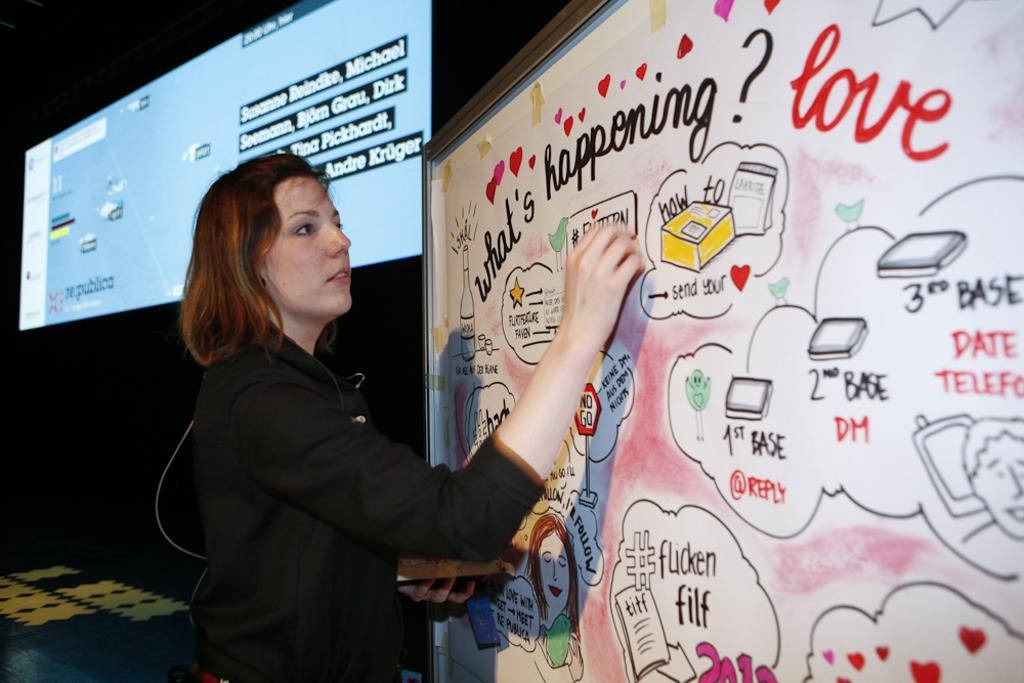<image>
Offer a succinct explanation of the picture presented. a person writing on a surface with the word love near 